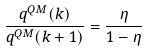Convert formula to latex. <formula><loc_0><loc_0><loc_500><loc_500>\frac { q ^ { Q M } ( k ) } { q ^ { Q M } ( k + 1 ) } = \frac { \eta } { 1 - \eta }</formula> 